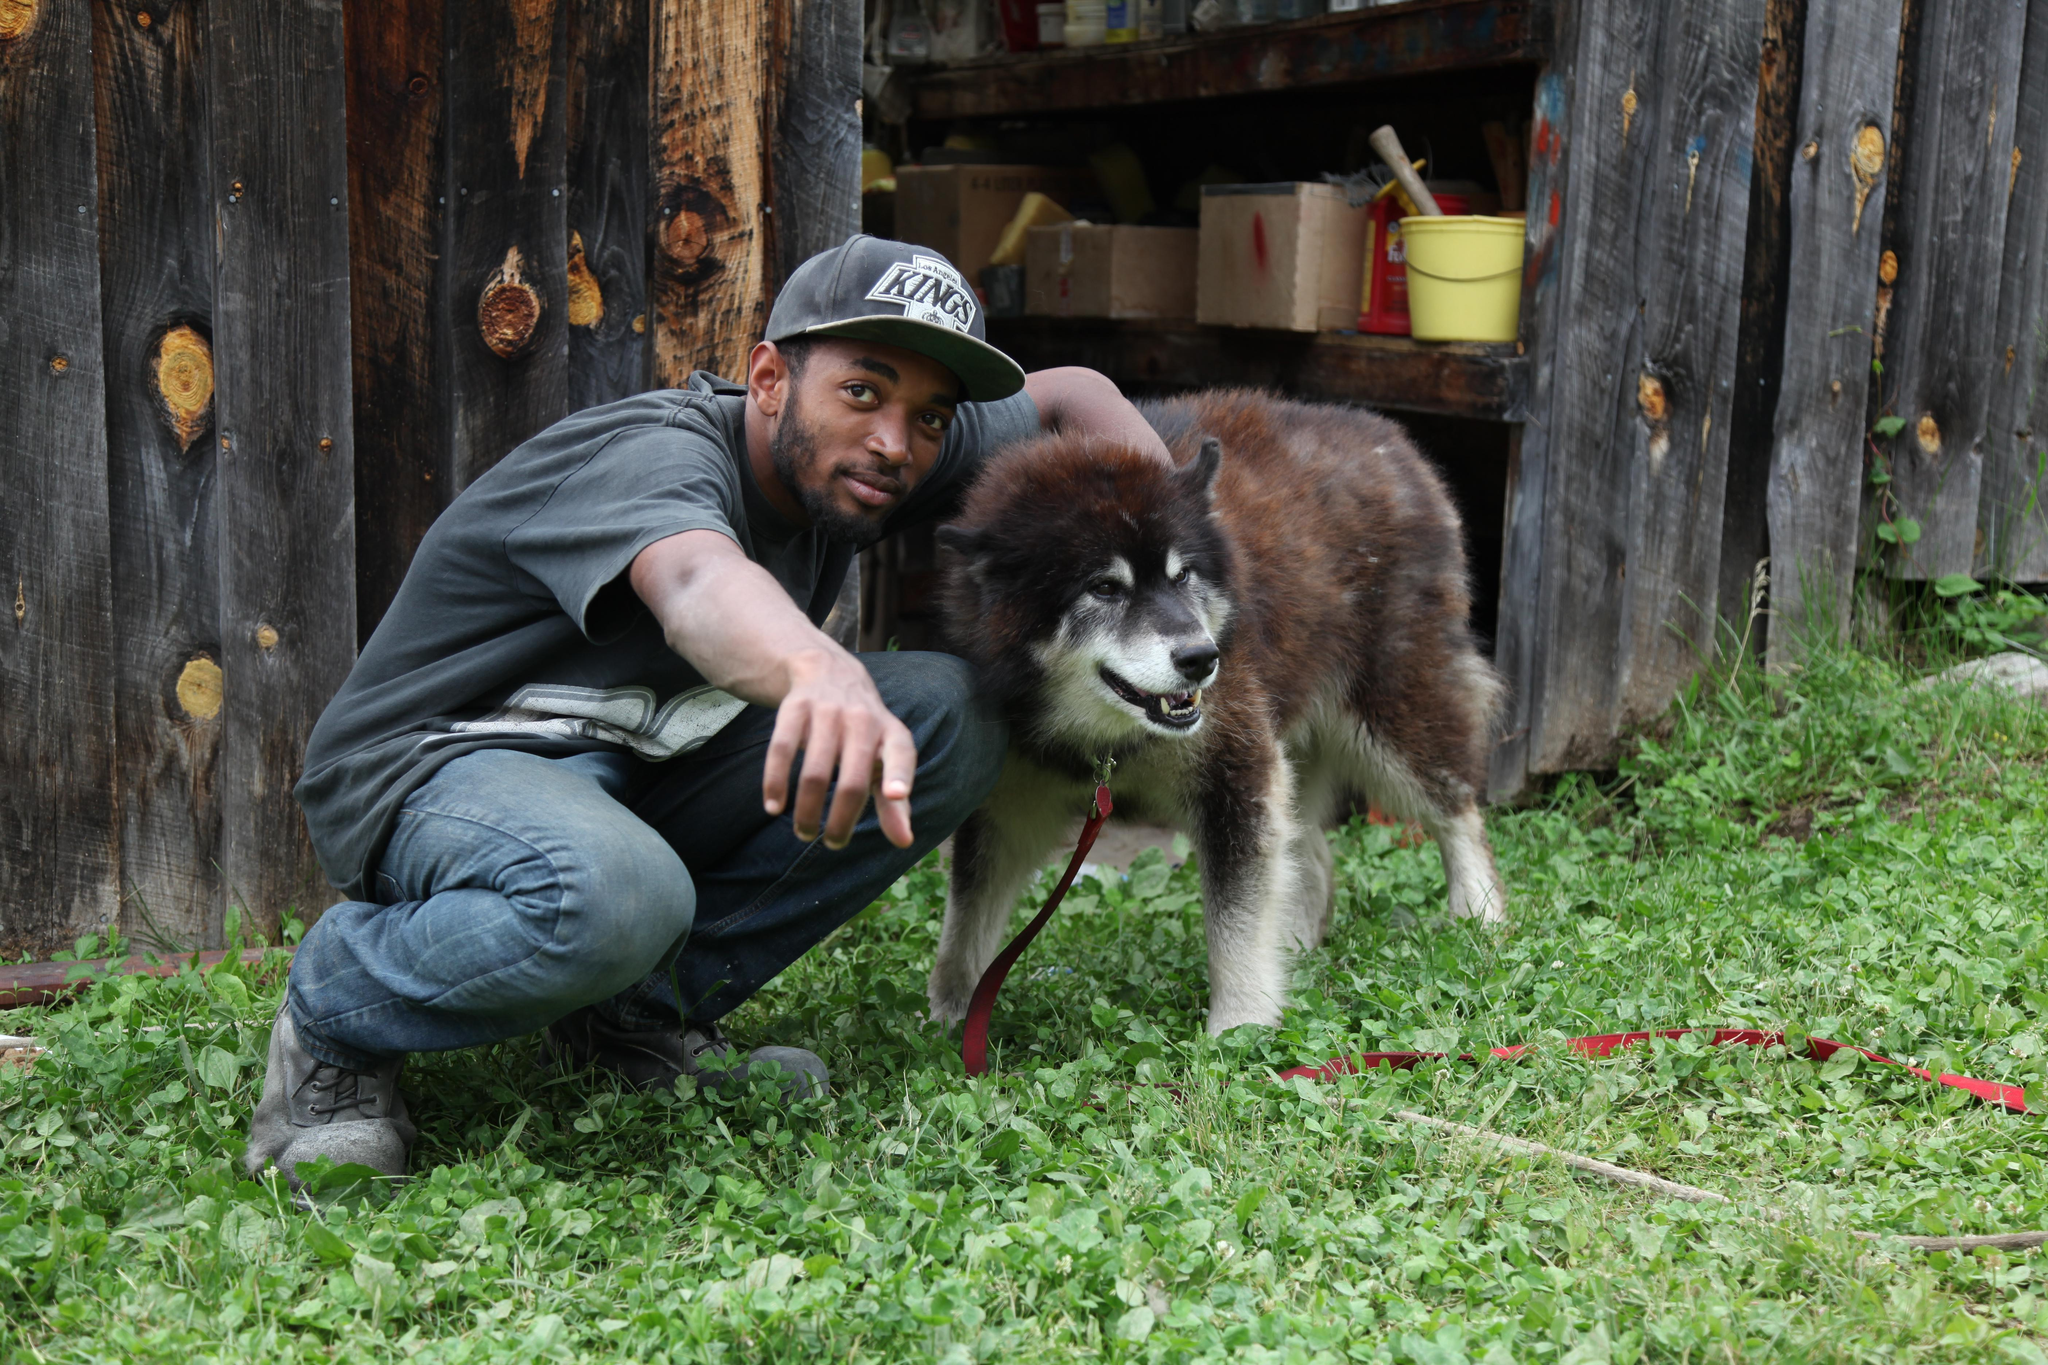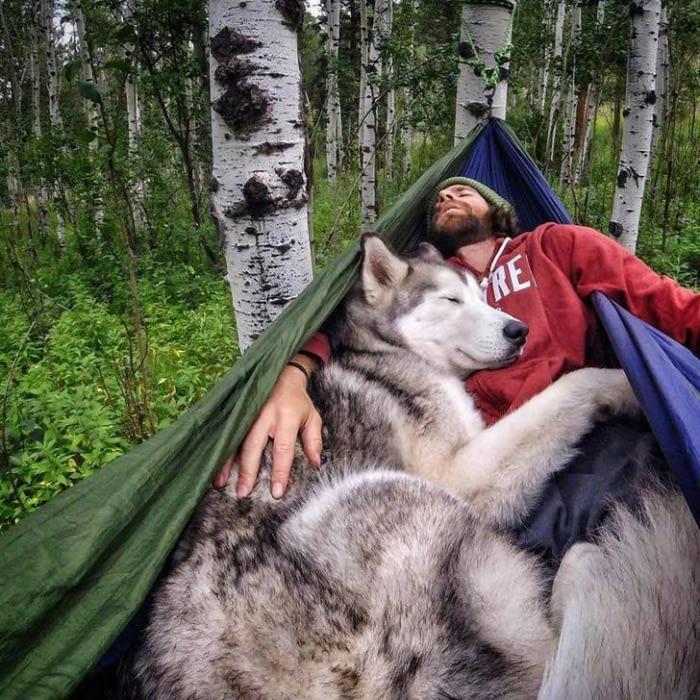The first image is the image on the left, the second image is the image on the right. For the images displayed, is the sentence "There are only two dogs." factually correct? Answer yes or no. Yes. The first image is the image on the left, the second image is the image on the right. Given the left and right images, does the statement "No image contains more than one dog, all dogs are husky-type, and the image on the left shows a dog standing on all fours." hold true? Answer yes or no. Yes. 